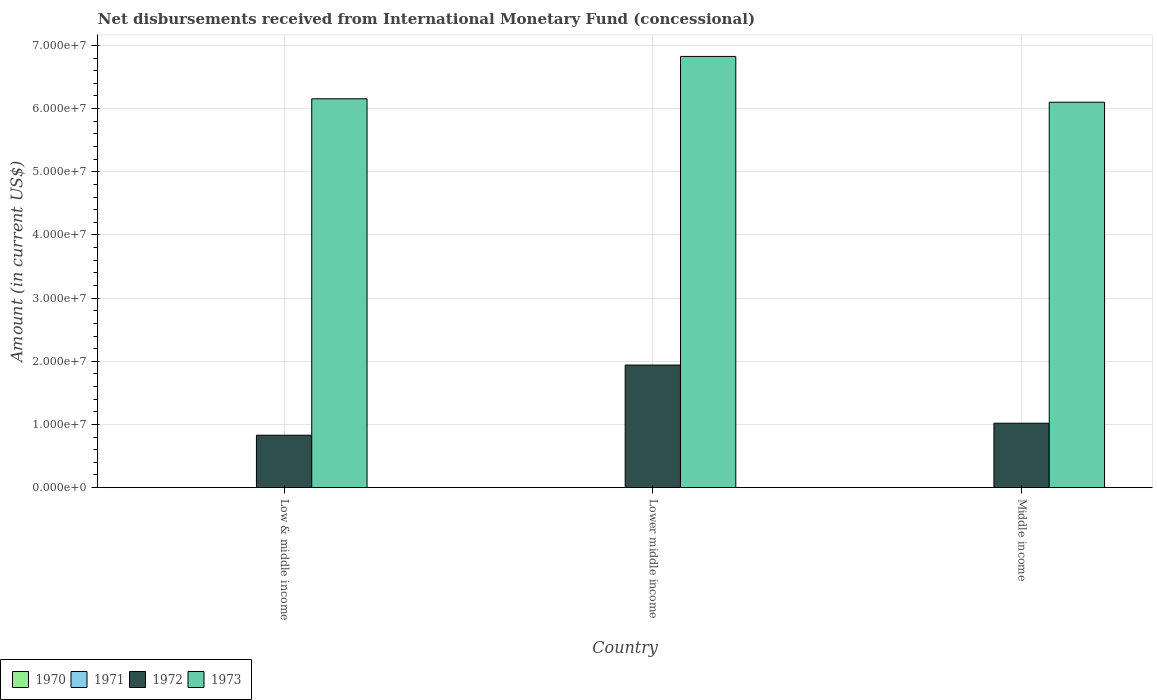How many different coloured bars are there?
Keep it short and to the point. 2. Are the number of bars on each tick of the X-axis equal?
Provide a short and direct response. Yes. What is the label of the 2nd group of bars from the left?
Provide a short and direct response. Lower middle income. What is the amount of disbursements received from International Monetary Fund in 1972 in Lower middle income?
Your answer should be compact. 1.94e+07. Across all countries, what is the maximum amount of disbursements received from International Monetary Fund in 1972?
Ensure brevity in your answer.  1.94e+07. Across all countries, what is the minimum amount of disbursements received from International Monetary Fund in 1973?
Make the answer very short. 6.10e+07. In which country was the amount of disbursements received from International Monetary Fund in 1972 maximum?
Make the answer very short. Lower middle income. What is the total amount of disbursements received from International Monetary Fund in 1972 in the graph?
Keep it short and to the point. 3.79e+07. What is the difference between the amount of disbursements received from International Monetary Fund in 1973 in Lower middle income and that in Middle income?
Your answer should be very brief. 7.25e+06. What is the difference between the amount of disbursements received from International Monetary Fund in 1970 in Lower middle income and the amount of disbursements received from International Monetary Fund in 1973 in Middle income?
Your answer should be very brief. -6.10e+07. What is the average amount of disbursements received from International Monetary Fund in 1970 per country?
Provide a short and direct response. 0. What is the difference between the amount of disbursements received from International Monetary Fund of/in 1973 and amount of disbursements received from International Monetary Fund of/in 1972 in Lower middle income?
Your answer should be very brief. 4.89e+07. What is the ratio of the amount of disbursements received from International Monetary Fund in 1973 in Low & middle income to that in Middle income?
Your answer should be compact. 1.01. Is the difference between the amount of disbursements received from International Monetary Fund in 1973 in Lower middle income and Middle income greater than the difference between the amount of disbursements received from International Monetary Fund in 1972 in Lower middle income and Middle income?
Keep it short and to the point. No. What is the difference between the highest and the second highest amount of disbursements received from International Monetary Fund in 1973?
Offer a terse response. -7.25e+06. What is the difference between the highest and the lowest amount of disbursements received from International Monetary Fund in 1972?
Your answer should be very brief. 1.11e+07. In how many countries, is the amount of disbursements received from International Monetary Fund in 1972 greater than the average amount of disbursements received from International Monetary Fund in 1972 taken over all countries?
Provide a succinct answer. 1. Is the sum of the amount of disbursements received from International Monetary Fund in 1972 in Low & middle income and Lower middle income greater than the maximum amount of disbursements received from International Monetary Fund in 1970 across all countries?
Keep it short and to the point. Yes. Is it the case that in every country, the sum of the amount of disbursements received from International Monetary Fund in 1973 and amount of disbursements received from International Monetary Fund in 1972 is greater than the amount of disbursements received from International Monetary Fund in 1970?
Your response must be concise. Yes. Are all the bars in the graph horizontal?
Offer a very short reply. No. Does the graph contain grids?
Provide a short and direct response. Yes. How many legend labels are there?
Offer a terse response. 4. What is the title of the graph?
Offer a terse response. Net disbursements received from International Monetary Fund (concessional). What is the Amount (in current US$) in 1972 in Low & middle income?
Make the answer very short. 8.30e+06. What is the Amount (in current US$) in 1973 in Low & middle income?
Give a very brief answer. 6.16e+07. What is the Amount (in current US$) of 1970 in Lower middle income?
Offer a very short reply. 0. What is the Amount (in current US$) in 1971 in Lower middle income?
Ensure brevity in your answer.  0. What is the Amount (in current US$) of 1972 in Lower middle income?
Offer a very short reply. 1.94e+07. What is the Amount (in current US$) of 1973 in Lower middle income?
Your response must be concise. 6.83e+07. What is the Amount (in current US$) of 1970 in Middle income?
Your answer should be very brief. 0. What is the Amount (in current US$) of 1972 in Middle income?
Ensure brevity in your answer.  1.02e+07. What is the Amount (in current US$) of 1973 in Middle income?
Ensure brevity in your answer.  6.10e+07. Across all countries, what is the maximum Amount (in current US$) in 1972?
Provide a succinct answer. 1.94e+07. Across all countries, what is the maximum Amount (in current US$) of 1973?
Give a very brief answer. 6.83e+07. Across all countries, what is the minimum Amount (in current US$) in 1972?
Offer a very short reply. 8.30e+06. Across all countries, what is the minimum Amount (in current US$) in 1973?
Make the answer very short. 6.10e+07. What is the total Amount (in current US$) in 1970 in the graph?
Give a very brief answer. 0. What is the total Amount (in current US$) of 1971 in the graph?
Provide a short and direct response. 0. What is the total Amount (in current US$) in 1972 in the graph?
Offer a terse response. 3.79e+07. What is the total Amount (in current US$) of 1973 in the graph?
Ensure brevity in your answer.  1.91e+08. What is the difference between the Amount (in current US$) in 1972 in Low & middle income and that in Lower middle income?
Your response must be concise. -1.11e+07. What is the difference between the Amount (in current US$) of 1973 in Low & middle income and that in Lower middle income?
Give a very brief answer. -6.70e+06. What is the difference between the Amount (in current US$) of 1972 in Low & middle income and that in Middle income?
Your answer should be compact. -1.90e+06. What is the difference between the Amount (in current US$) in 1973 in Low & middle income and that in Middle income?
Give a very brief answer. 5.46e+05. What is the difference between the Amount (in current US$) of 1972 in Lower middle income and that in Middle income?
Your answer should be very brief. 9.21e+06. What is the difference between the Amount (in current US$) in 1973 in Lower middle income and that in Middle income?
Ensure brevity in your answer.  7.25e+06. What is the difference between the Amount (in current US$) in 1972 in Low & middle income and the Amount (in current US$) in 1973 in Lower middle income?
Offer a very short reply. -6.00e+07. What is the difference between the Amount (in current US$) of 1972 in Low & middle income and the Amount (in current US$) of 1973 in Middle income?
Offer a terse response. -5.27e+07. What is the difference between the Amount (in current US$) of 1972 in Lower middle income and the Amount (in current US$) of 1973 in Middle income?
Provide a short and direct response. -4.16e+07. What is the average Amount (in current US$) in 1970 per country?
Give a very brief answer. 0. What is the average Amount (in current US$) in 1971 per country?
Give a very brief answer. 0. What is the average Amount (in current US$) in 1972 per country?
Offer a terse response. 1.26e+07. What is the average Amount (in current US$) in 1973 per country?
Offer a terse response. 6.36e+07. What is the difference between the Amount (in current US$) of 1972 and Amount (in current US$) of 1973 in Low & middle income?
Offer a terse response. -5.33e+07. What is the difference between the Amount (in current US$) of 1972 and Amount (in current US$) of 1973 in Lower middle income?
Keep it short and to the point. -4.89e+07. What is the difference between the Amount (in current US$) of 1972 and Amount (in current US$) of 1973 in Middle income?
Keep it short and to the point. -5.08e+07. What is the ratio of the Amount (in current US$) of 1972 in Low & middle income to that in Lower middle income?
Keep it short and to the point. 0.43. What is the ratio of the Amount (in current US$) in 1973 in Low & middle income to that in Lower middle income?
Provide a succinct answer. 0.9. What is the ratio of the Amount (in current US$) of 1972 in Low & middle income to that in Middle income?
Provide a succinct answer. 0.81. What is the ratio of the Amount (in current US$) in 1972 in Lower middle income to that in Middle income?
Your answer should be compact. 1.9. What is the ratio of the Amount (in current US$) in 1973 in Lower middle income to that in Middle income?
Provide a short and direct response. 1.12. What is the difference between the highest and the second highest Amount (in current US$) of 1972?
Provide a succinct answer. 9.21e+06. What is the difference between the highest and the second highest Amount (in current US$) in 1973?
Provide a short and direct response. 6.70e+06. What is the difference between the highest and the lowest Amount (in current US$) of 1972?
Give a very brief answer. 1.11e+07. What is the difference between the highest and the lowest Amount (in current US$) of 1973?
Make the answer very short. 7.25e+06. 